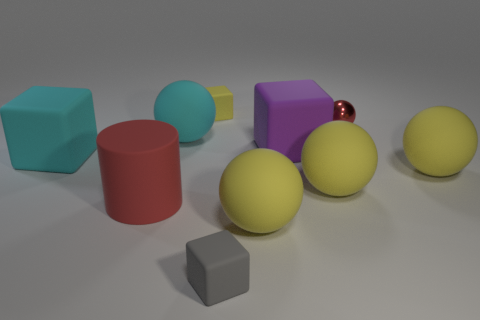There is a matte cylinder that is the same color as the tiny metal object; what size is it?
Your answer should be very brief. Large. There is a object that is both behind the purple block and in front of the metallic object; what is its color?
Keep it short and to the point. Cyan. The large rubber cube that is on the left side of the yellow matte object left of the small object that is in front of the tiny red metal sphere is what color?
Keep it short and to the point. Cyan. There is a metallic ball that is the same size as the gray matte cube; what is its color?
Your response must be concise. Red. There is a object that is behind the small thing to the right of the small rubber cube that is in front of the cyan sphere; what shape is it?
Make the answer very short. Cube. What shape is the metal object that is the same color as the large cylinder?
Give a very brief answer. Sphere. What number of things are either big rubber cylinders or yellow rubber balls that are behind the red rubber cylinder?
Ensure brevity in your answer.  3. Is the size of the rubber cube that is in front of the red cylinder the same as the tiny yellow object?
Your answer should be compact. Yes. There is a red thing behind the big cyan block; what is its material?
Your answer should be very brief. Metal. Is the number of cubes that are left of the red matte cylinder the same as the number of tiny rubber blocks that are in front of the red metallic sphere?
Ensure brevity in your answer.  Yes. 